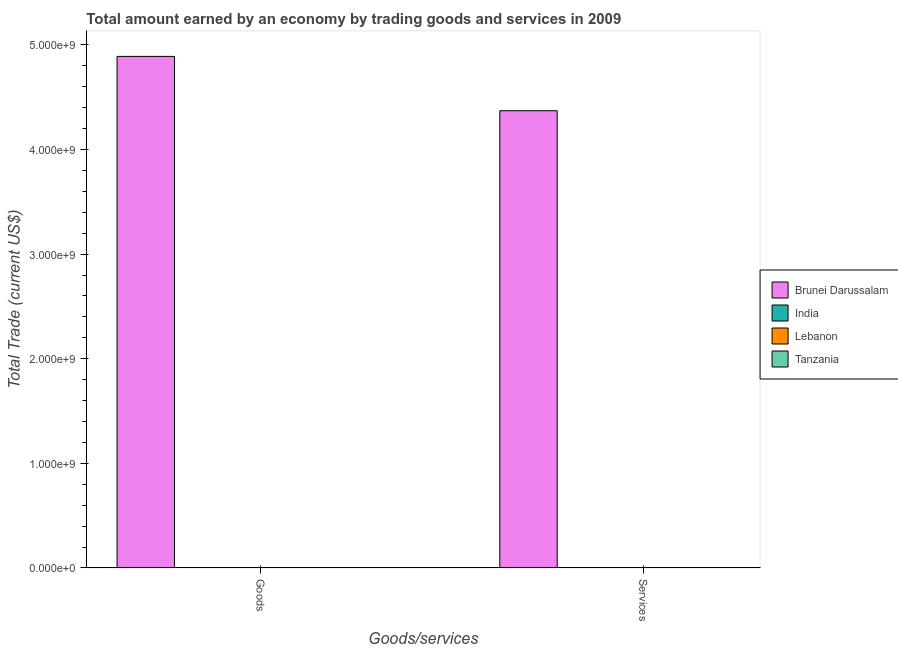How many different coloured bars are there?
Offer a terse response. 1. What is the label of the 2nd group of bars from the left?
Provide a short and direct response. Services. Across all countries, what is the maximum amount earned by trading services?
Give a very brief answer. 4.37e+09. In which country was the amount earned by trading goods maximum?
Provide a short and direct response. Brunei Darussalam. What is the total amount earned by trading services in the graph?
Your answer should be compact. 4.37e+09. What is the difference between the amount earned by trading goods in Tanzania and the amount earned by trading services in India?
Provide a succinct answer. 0. What is the average amount earned by trading goods per country?
Your answer should be compact. 1.22e+09. What is the difference between the amount earned by trading goods and amount earned by trading services in Brunei Darussalam?
Give a very brief answer. 5.19e+08. How many bars are there?
Make the answer very short. 2. Are all the bars in the graph horizontal?
Provide a succinct answer. No. What is the difference between two consecutive major ticks on the Y-axis?
Provide a short and direct response. 1.00e+09. How many legend labels are there?
Your response must be concise. 4. How are the legend labels stacked?
Your response must be concise. Vertical. What is the title of the graph?
Keep it short and to the point. Total amount earned by an economy by trading goods and services in 2009. What is the label or title of the X-axis?
Provide a short and direct response. Goods/services. What is the label or title of the Y-axis?
Give a very brief answer. Total Trade (current US$). What is the Total Trade (current US$) of Brunei Darussalam in Goods?
Provide a succinct answer. 4.89e+09. What is the Total Trade (current US$) in Lebanon in Goods?
Ensure brevity in your answer.  0. What is the Total Trade (current US$) of Brunei Darussalam in Services?
Your answer should be compact. 4.37e+09. Across all Goods/services, what is the maximum Total Trade (current US$) in Brunei Darussalam?
Keep it short and to the point. 4.89e+09. Across all Goods/services, what is the minimum Total Trade (current US$) in Brunei Darussalam?
Provide a short and direct response. 4.37e+09. What is the total Total Trade (current US$) in Brunei Darussalam in the graph?
Make the answer very short. 9.26e+09. What is the difference between the Total Trade (current US$) of Brunei Darussalam in Goods and that in Services?
Your response must be concise. 5.19e+08. What is the average Total Trade (current US$) in Brunei Darussalam per Goods/services?
Your response must be concise. 4.63e+09. What is the ratio of the Total Trade (current US$) of Brunei Darussalam in Goods to that in Services?
Your answer should be compact. 1.12. What is the difference between the highest and the second highest Total Trade (current US$) in Brunei Darussalam?
Your answer should be very brief. 5.19e+08. What is the difference between the highest and the lowest Total Trade (current US$) of Brunei Darussalam?
Keep it short and to the point. 5.19e+08. 